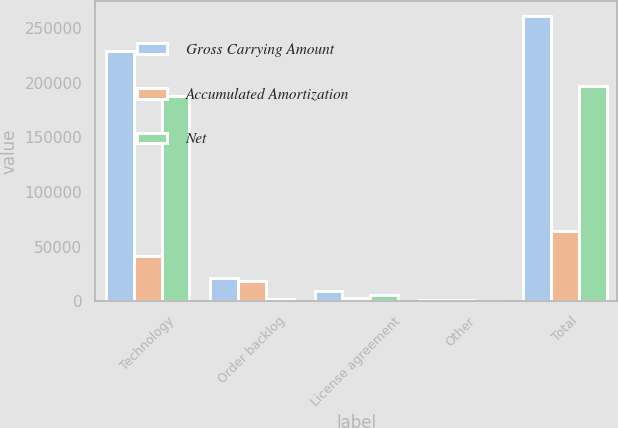Convert chart to OTSL. <chart><loc_0><loc_0><loc_500><loc_500><stacked_bar_chart><ecel><fcel>Technology<fcel>Order backlog<fcel>License agreement<fcel>Other<fcel>Total<nl><fcel>Gross Carrying Amount<fcel>228884<fcel>21340<fcel>9373<fcel>1600<fcel>261197<nl><fcel>Accumulated Amortization<fcel>41276<fcel>18914<fcel>3272<fcel>970<fcel>64432<nl><fcel>Net<fcel>187608<fcel>2426<fcel>6101<fcel>630<fcel>196765<nl></chart> 